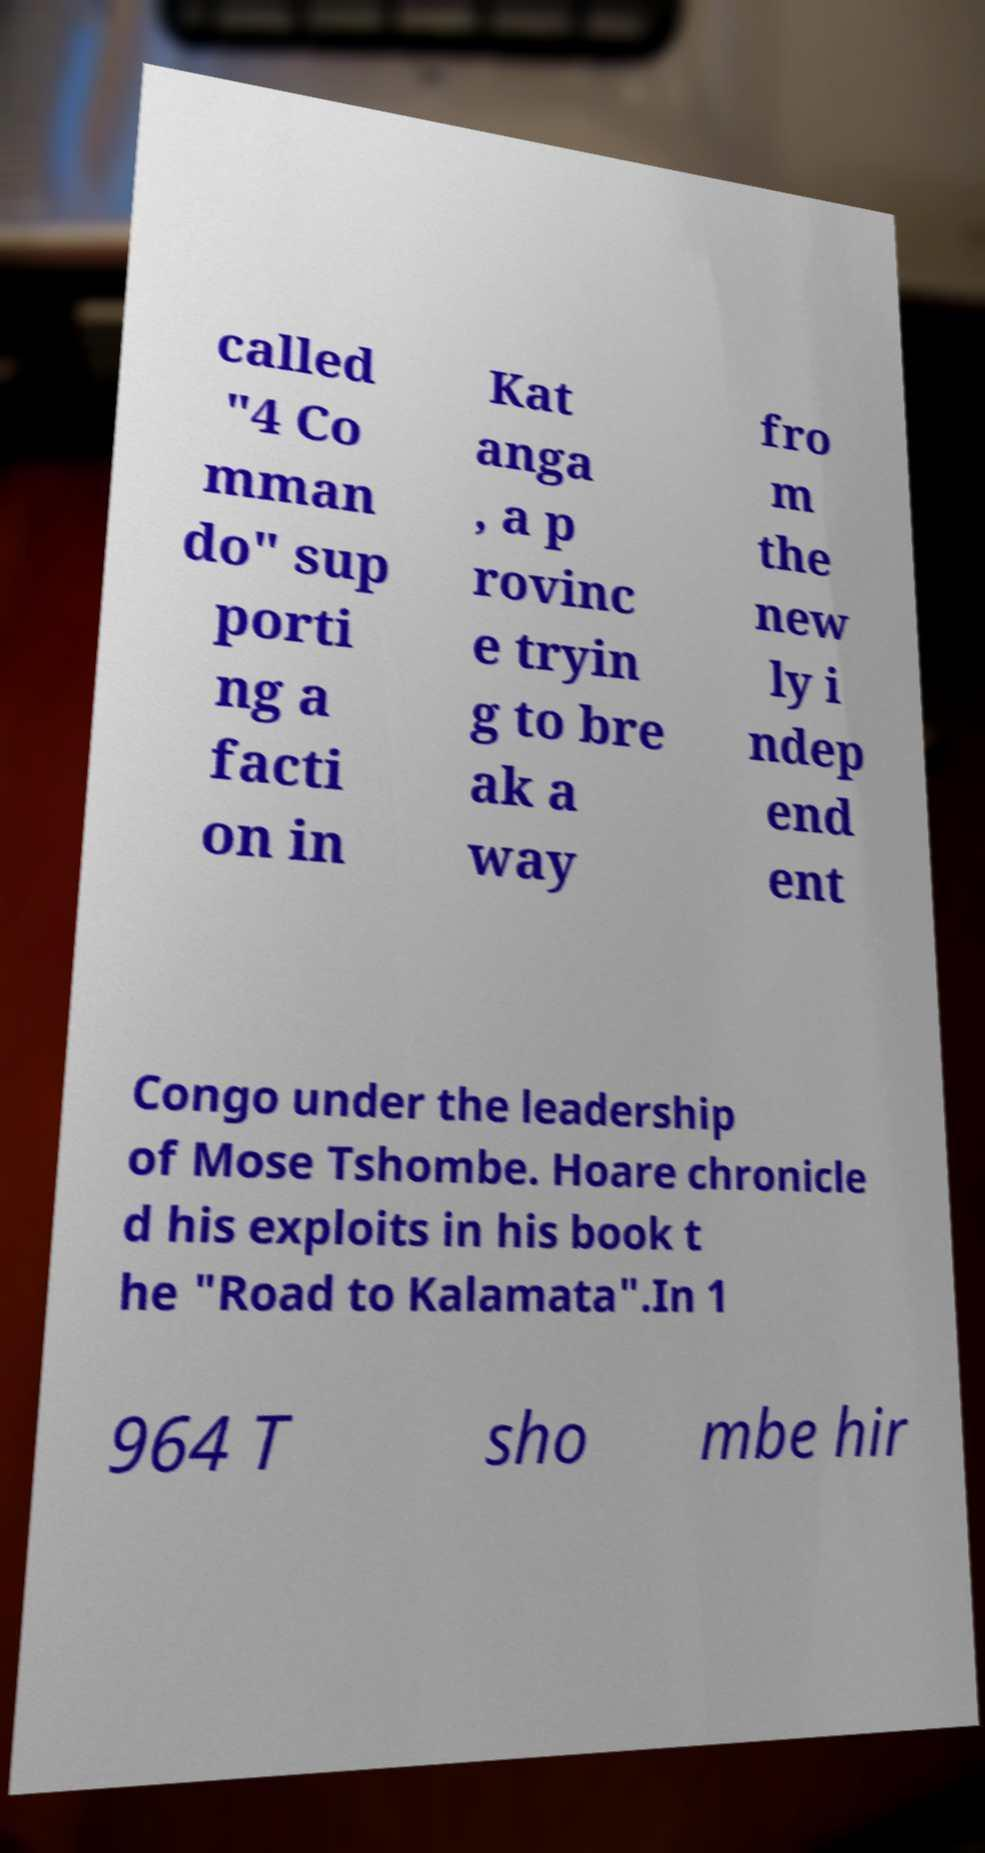Can you accurately transcribe the text from the provided image for me? called "4 Co mman do" sup porti ng a facti on in Kat anga , a p rovinc e tryin g to bre ak a way fro m the new ly i ndep end ent Congo under the leadership of Mose Tshombe. Hoare chronicle d his exploits in his book t he "Road to Kalamata".In 1 964 T sho mbe hir 